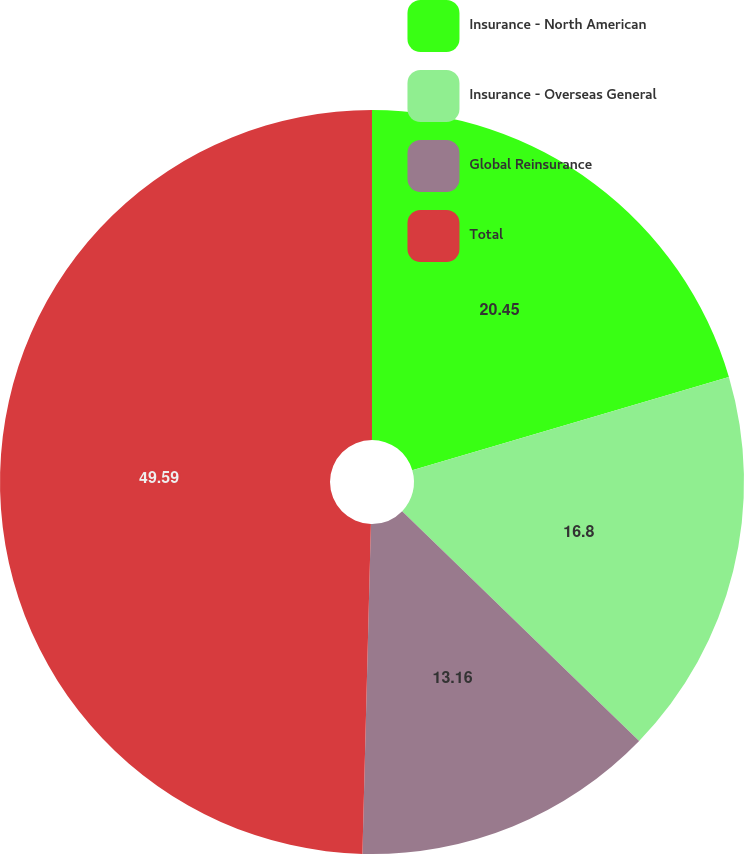Convert chart. <chart><loc_0><loc_0><loc_500><loc_500><pie_chart><fcel>Insurance - North American<fcel>Insurance - Overseas General<fcel>Global Reinsurance<fcel>Total<nl><fcel>20.45%<fcel>16.8%<fcel>13.16%<fcel>49.59%<nl></chart> 